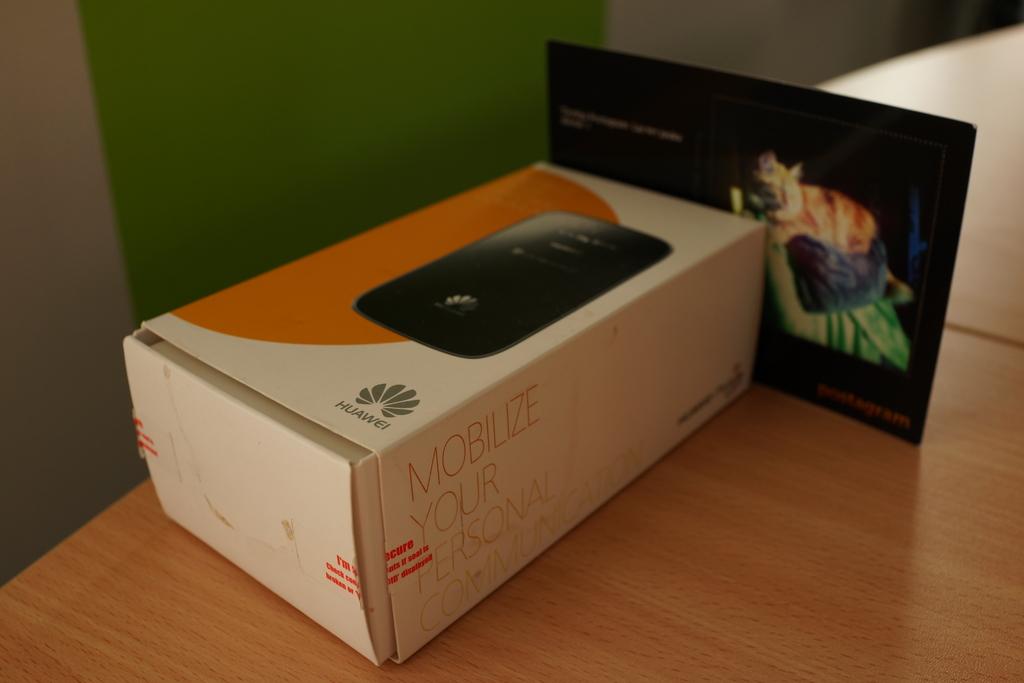What brand name is on this box?
Provide a succinct answer. Huawei. Can you mobilize your personal communication?
Your response must be concise. Yes. 